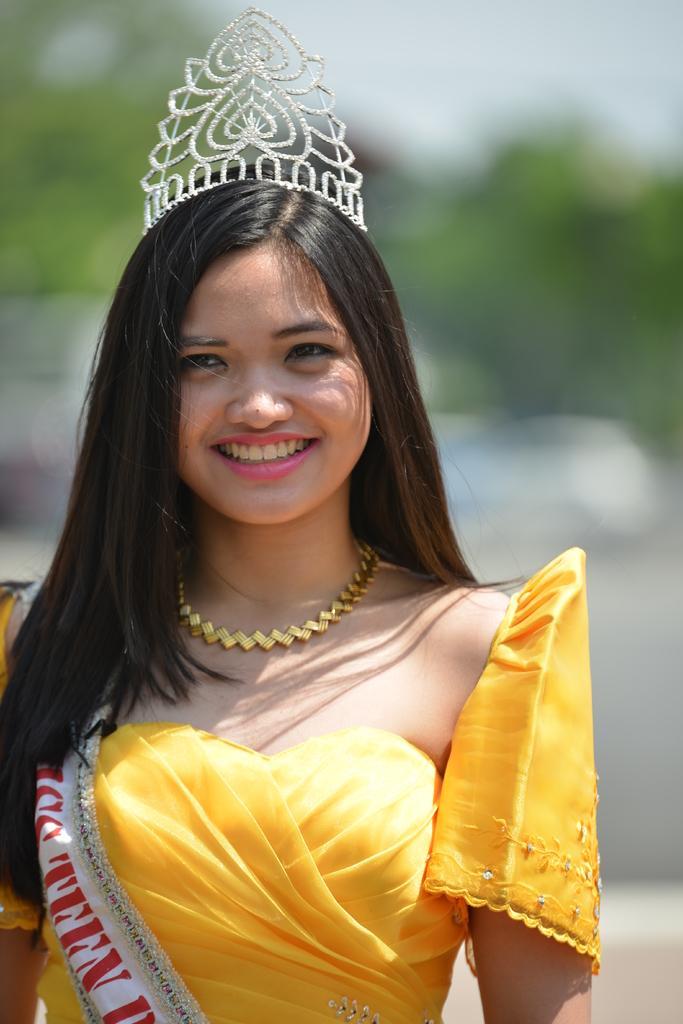Can you describe this image briefly? In this image, we can see a woman is smiling and wearing a crown on her head. She wore a sash. Background we can see the blur view. 